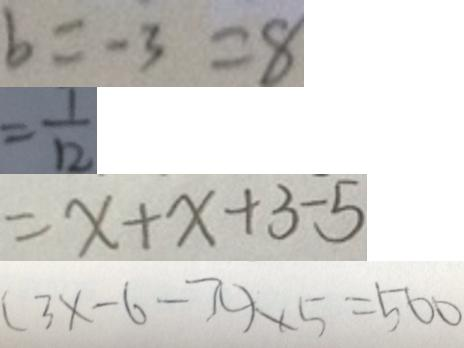<formula> <loc_0><loc_0><loc_500><loc_500>b = - 3 = 8 
 = \frac { 1 } { 1 2 } 
 = x + x + 3 - 5 
 ( 3 x - 6 - \pi ) \times 5 = 5 0 0</formula> 